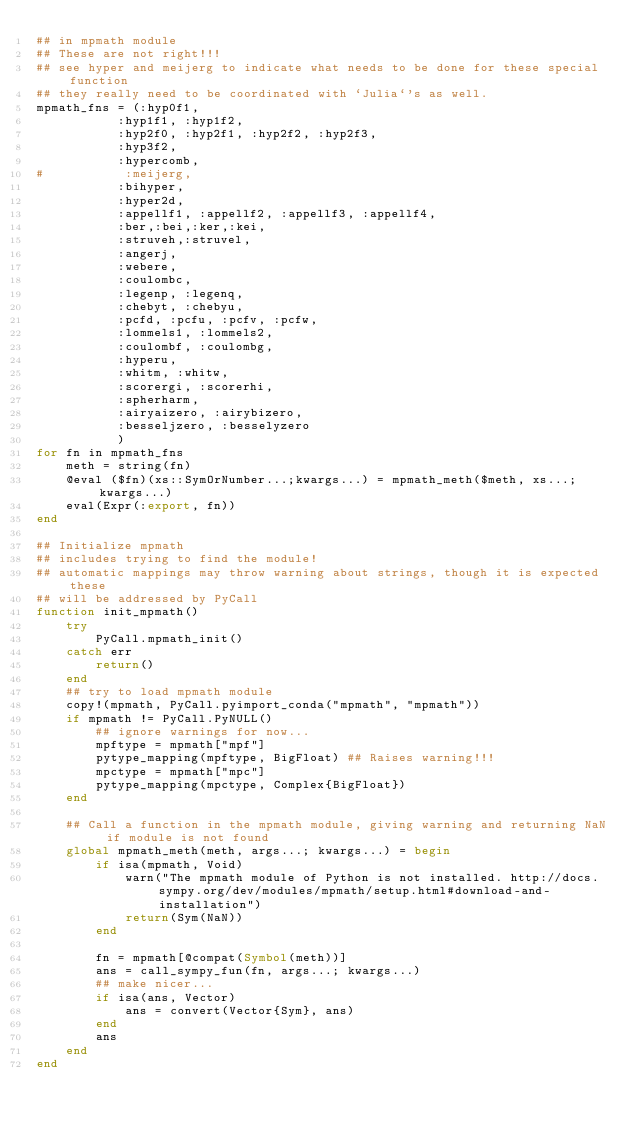<code> <loc_0><loc_0><loc_500><loc_500><_Julia_>## in mpmath module
## These are not right!!!
## see hyper and meijerg to indicate what needs to be done for these special function
## they really need to be coordinated with `Julia`'s as well.
mpmath_fns = (:hyp0f1, 
           :hyp1f1, :hyp1f2, 
           :hyp2f0, :hyp2f1, :hyp2f2, :hyp2f3,
           :hyp3f2,
           :hypercomb,
#           :meijerg,
           :bihyper,
           :hyper2d,
           :appellf1, :appellf2, :appellf3, :appellf4,
           :ber,:bei,:ker,:kei,
           :struveh,:struvel,
           :angerj,
           :webere,
           :coulombc,
           :legenp, :legenq,
           :chebyt, :chebyu, 
           :pcfd, :pcfu, :pcfv, :pcfw,
           :lommels1, :lommels2,
           :coulombf, :coulombg,
           :hyperu,
           :whitm, :whitw,
           :scorergi, :scorerhi,
           :spherharm,
           :airyaizero, :airybizero, 
           :besseljzero, :besselyzero
           )
for fn in mpmath_fns
    meth = string(fn)
    @eval ($fn)(xs::SymOrNumber...;kwargs...) = mpmath_meth($meth, xs...; kwargs...)
    eval(Expr(:export, fn))
end

## Initialize mpmath
## includes trying to find the module!
## automatic mappings may throw warning about strings, though it is expected these
## will be addressed by PyCall
function init_mpmath()
    try
        PyCall.mpmath_init()
    catch err
        return()
    end
    ## try to load mpmath module
    copy!(mpmath, PyCall.pyimport_conda("mpmath", "mpmath"))
    if mpmath != PyCall.PyNULL()
        ## ignore warnings for now...
        mpftype = mpmath["mpf"]
        pytype_mapping(mpftype, BigFloat) ## Raises warning!!!
        mpctype = mpmath["mpc"]
        pytype_mapping(mpctype, Complex{BigFloat})
    end

    ## Call a function in the mpmath module, giving warning and returning NaN if module is not found 
    global mpmath_meth(meth, args...; kwargs...) = begin
        if isa(mpmath, Void)
            warn("The mpmath module of Python is not installed. http://docs.sympy.org/dev/modules/mpmath/setup.html#download-and-installation")
            return(Sym(NaN))
        end

        fn = mpmath[@compat(Symbol(meth))]
        ans = call_sympy_fun(fn, args...; kwargs...)
        ## make nicer...
        if isa(ans, Vector)
            ans = convert(Vector{Sym}, ans)
        end
        ans
    end
end
</code> 